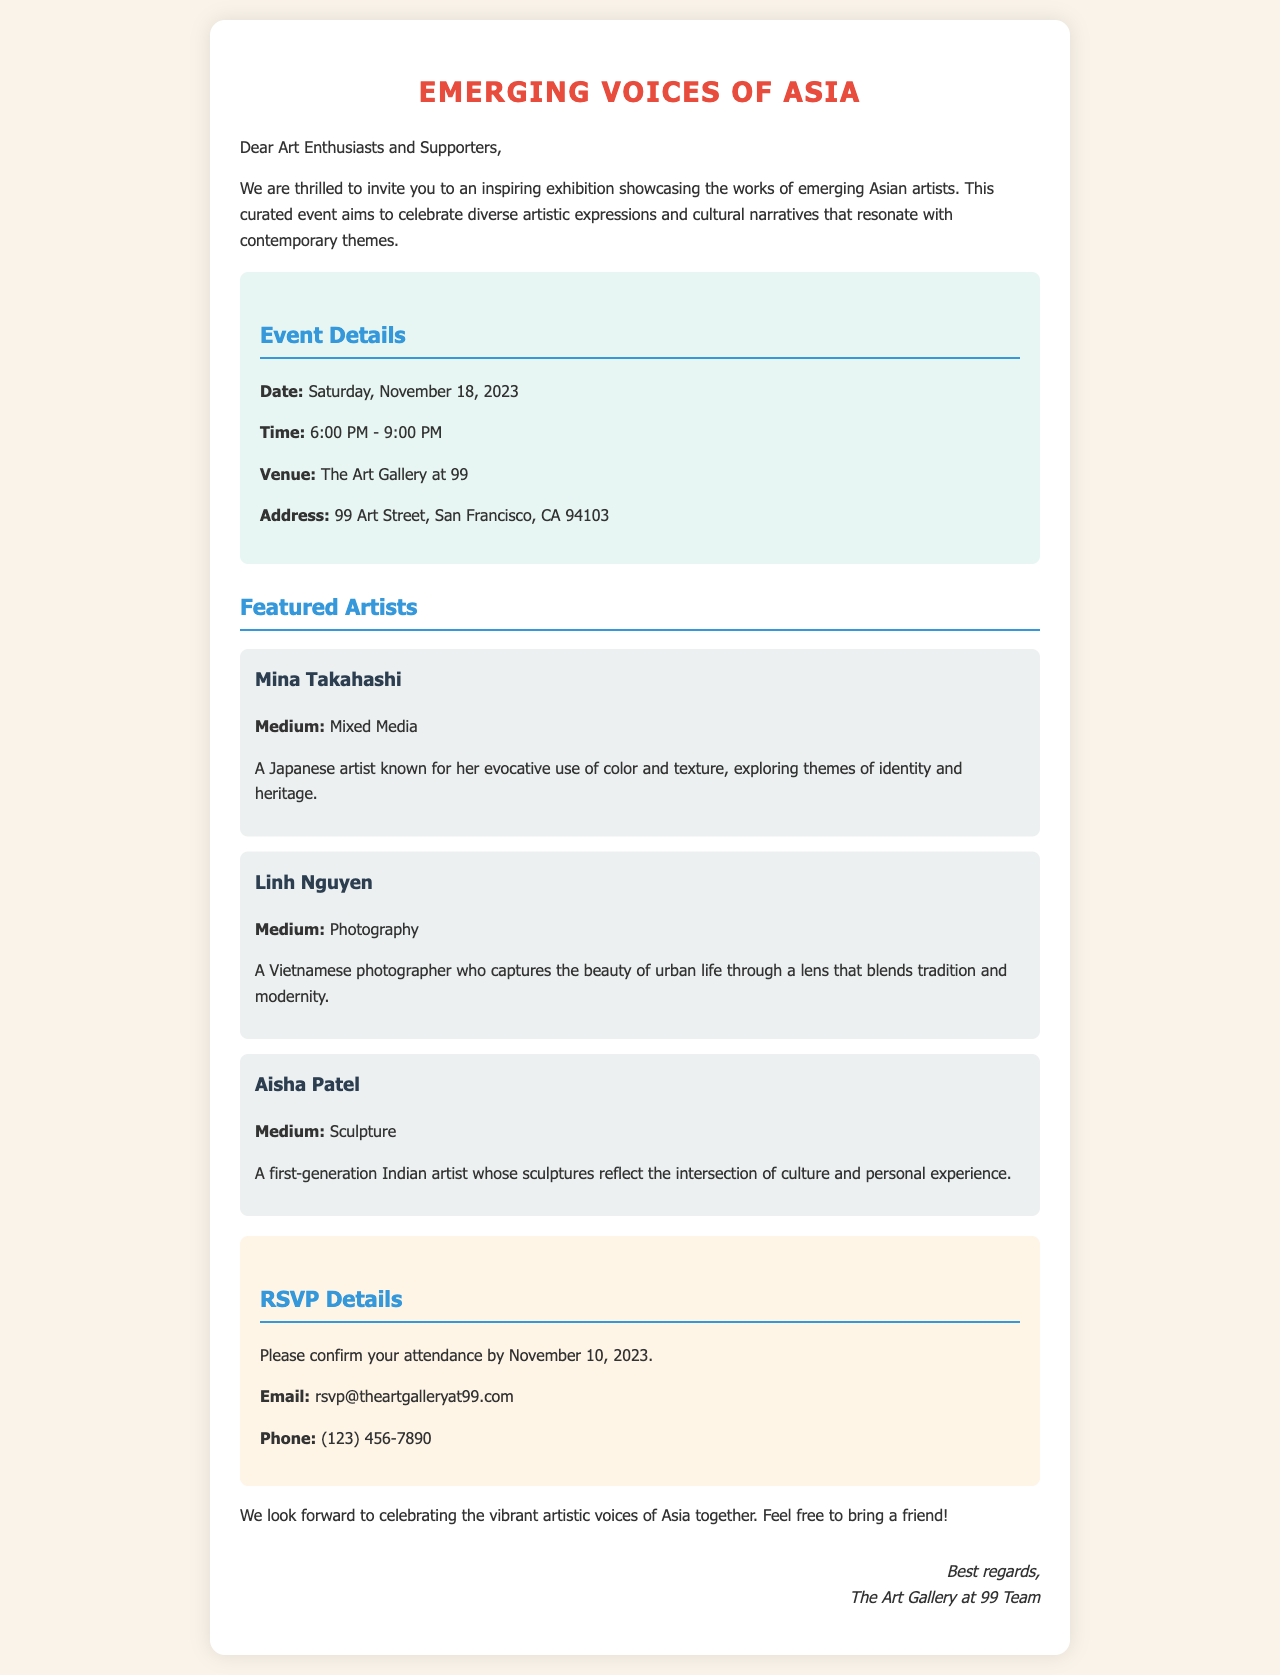What is the date of the exhibition? The date of the exhibition is explicitly mentioned in the document.
Answer: Saturday, November 18, 2023 What time does the exhibition start? The start time of the exhibition is specified in the event details section.
Answer: 6:00 PM Who is one of the featured artists? The document lists several artists, making this a straightforward information retrieval question.
Answer: Mina Takahashi What is the medium of Aisha Patel's artwork? This can be found in the description of Aisha Patel within the artist section.
Answer: Sculpture What is the RSVP deadline? The RSVP deadline is stated clearly in the RSVP details section.
Answer: November 10, 2023 What city is the art gallery located in? The city is mentioned in the event details as part of the address information.
Answer: San Francisco How many featured artists are mentioned in the document? This requires counting the distinct artist sections in the document.
Answer: Three What type of event is this document describing? The overall nature of the event can be deduced from the title and introduction.
Answer: Art Exhibition 